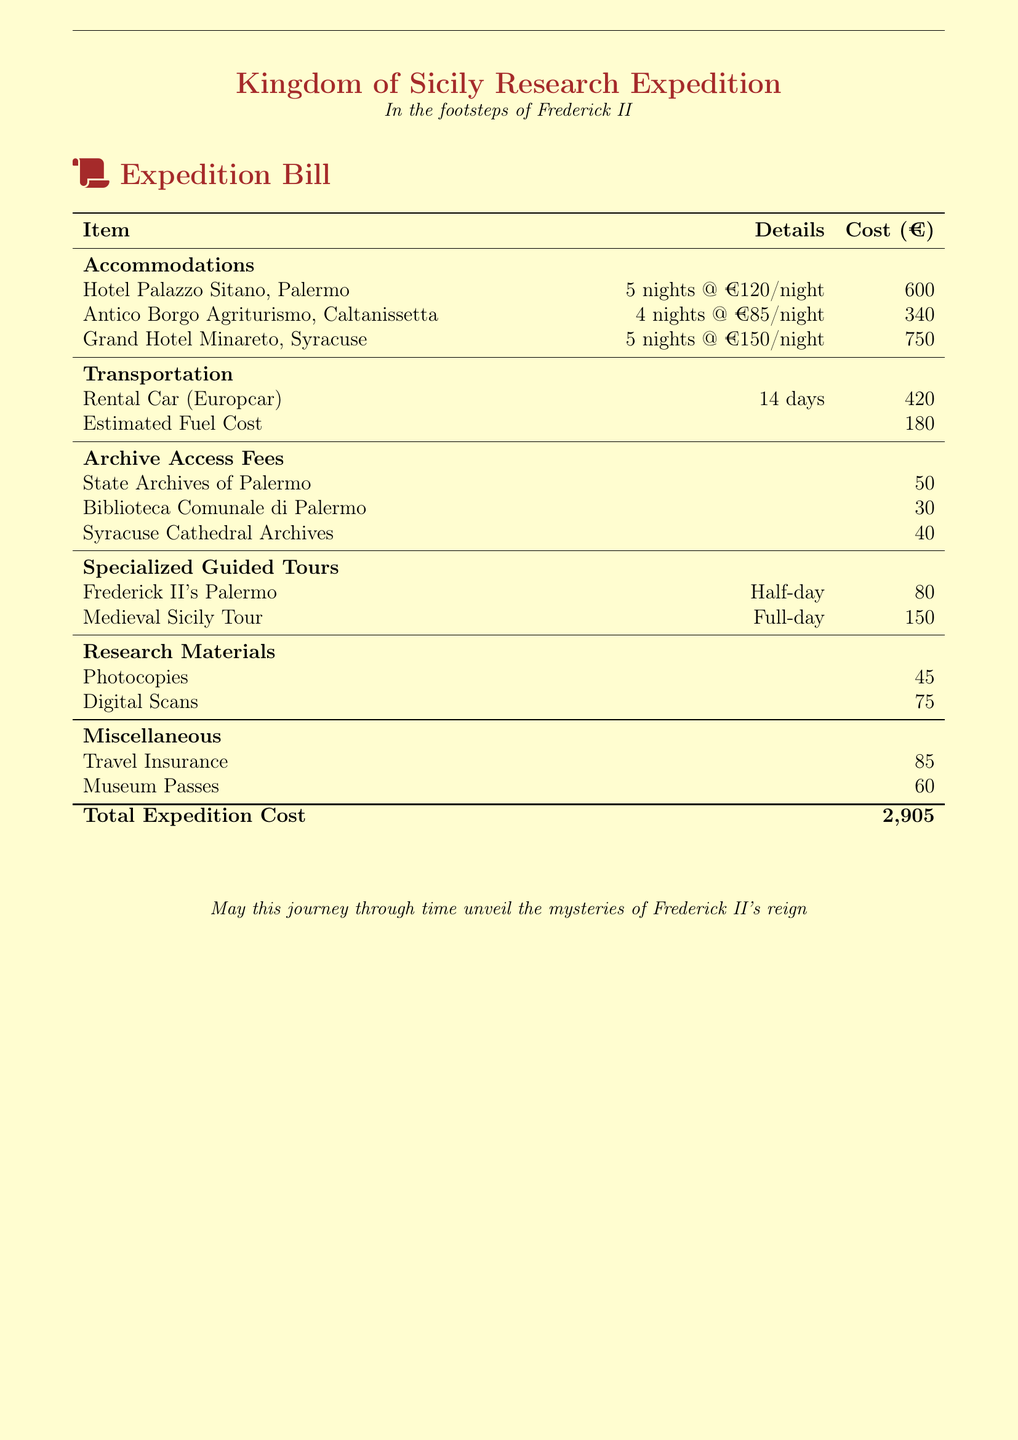What is the total expedition cost? The total cost is found at the bottom of the bill, summing all listed expenses.
Answer: 2,905 How many nights were spent at Hotel Palazzo Sitano? The details under accommodations specify the number of nights spent at each hotel.
Answer: 5 nights What was the cost for the Medieval Sicily Tour? The cost for the tour is specifically listed under specialized guided tours.
Answer: 150 What is the estimated fuel cost? The estimated fuel cost is included in the transportation section of the bill.
Answer: 180 How many nights were spent at Antico Borgo Agriturismo? The nights spent at this agriturismo is outlined in the accommodations section.
Answer: 4 nights What are the total archive access fees? This requires summing the individual access fees listed for each archive.
Answer: 120 How much was paid for travel insurance? The document lists travel insurance as a separate expense under miscellaneous.
Answer: 85 What is the total cost for accommodations? This is the sum of all accommodation costs listed in the accommodations section.
Answer: 1,690 